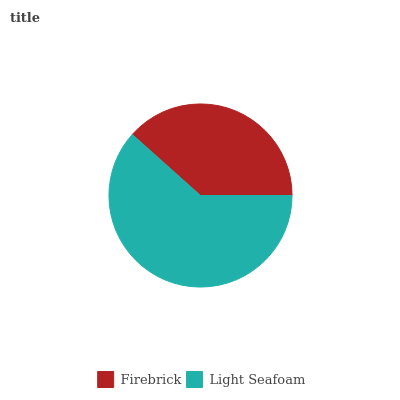Is Firebrick the minimum?
Answer yes or no. Yes. Is Light Seafoam the maximum?
Answer yes or no. Yes. Is Light Seafoam the minimum?
Answer yes or no. No. Is Light Seafoam greater than Firebrick?
Answer yes or no. Yes. Is Firebrick less than Light Seafoam?
Answer yes or no. Yes. Is Firebrick greater than Light Seafoam?
Answer yes or no. No. Is Light Seafoam less than Firebrick?
Answer yes or no. No. Is Light Seafoam the high median?
Answer yes or no. Yes. Is Firebrick the low median?
Answer yes or no. Yes. Is Firebrick the high median?
Answer yes or no. No. Is Light Seafoam the low median?
Answer yes or no. No. 